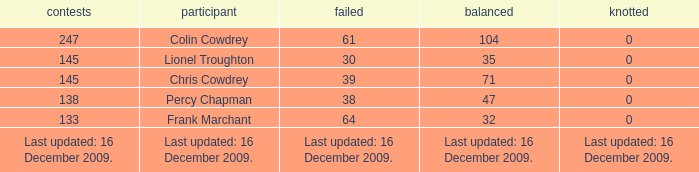I want to know the drawn that has a tie of 0 and the player is chris cowdrey 71.0. 